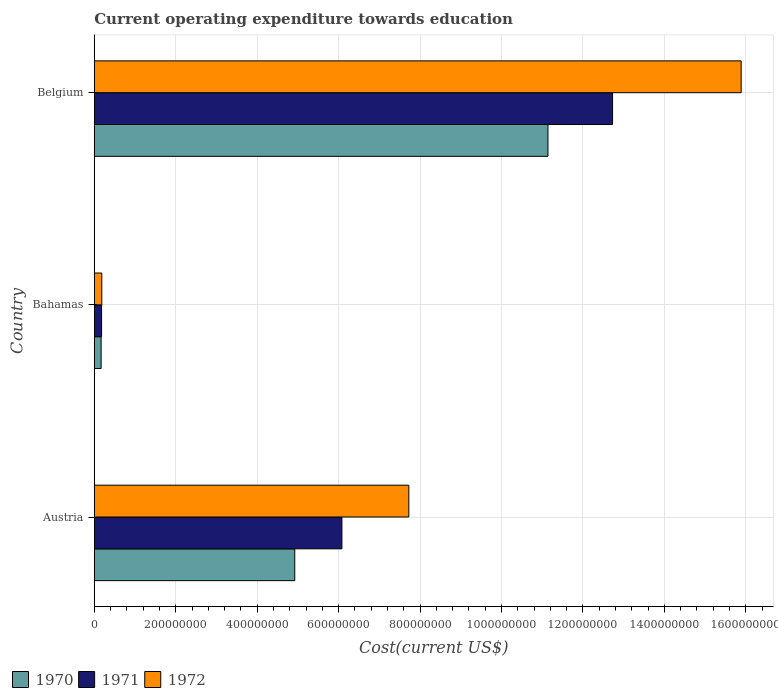How many groups of bars are there?
Your answer should be very brief. 3. Are the number of bars per tick equal to the number of legend labels?
Your answer should be compact. Yes. How many bars are there on the 1st tick from the top?
Offer a very short reply. 3. How many bars are there on the 3rd tick from the bottom?
Your response must be concise. 3. What is the label of the 2nd group of bars from the top?
Make the answer very short. Bahamas. What is the expenditure towards education in 1972 in Bahamas?
Your answer should be compact. 1.85e+07. Across all countries, what is the maximum expenditure towards education in 1970?
Offer a very short reply. 1.11e+09. Across all countries, what is the minimum expenditure towards education in 1972?
Ensure brevity in your answer.  1.85e+07. In which country was the expenditure towards education in 1970 maximum?
Ensure brevity in your answer.  Belgium. In which country was the expenditure towards education in 1971 minimum?
Your answer should be compact. Bahamas. What is the total expenditure towards education in 1970 in the graph?
Give a very brief answer. 1.62e+09. What is the difference between the expenditure towards education in 1971 in Bahamas and that in Belgium?
Your response must be concise. -1.26e+09. What is the difference between the expenditure towards education in 1970 in Bahamas and the expenditure towards education in 1972 in Belgium?
Offer a terse response. -1.57e+09. What is the average expenditure towards education in 1970 per country?
Offer a very short reply. 5.41e+08. What is the difference between the expenditure towards education in 1972 and expenditure towards education in 1971 in Bahamas?
Your response must be concise. 5.46e+05. What is the ratio of the expenditure towards education in 1970 in Austria to that in Bahamas?
Give a very brief answer. 29.29. Is the expenditure towards education in 1972 in Austria less than that in Belgium?
Provide a succinct answer. Yes. Is the difference between the expenditure towards education in 1972 in Austria and Bahamas greater than the difference between the expenditure towards education in 1971 in Austria and Bahamas?
Your answer should be very brief. Yes. What is the difference between the highest and the second highest expenditure towards education in 1971?
Offer a very short reply. 6.65e+08. What is the difference between the highest and the lowest expenditure towards education in 1971?
Provide a succinct answer. 1.26e+09. In how many countries, is the expenditure towards education in 1972 greater than the average expenditure towards education in 1972 taken over all countries?
Keep it short and to the point. 1. What does the 3rd bar from the top in Bahamas represents?
Ensure brevity in your answer.  1970. What does the 2nd bar from the bottom in Belgium represents?
Your answer should be compact. 1971. Is it the case that in every country, the sum of the expenditure towards education in 1970 and expenditure towards education in 1971 is greater than the expenditure towards education in 1972?
Your response must be concise. Yes. Are all the bars in the graph horizontal?
Provide a short and direct response. Yes. How many countries are there in the graph?
Your answer should be compact. 3. Does the graph contain any zero values?
Your answer should be very brief. No. Does the graph contain grids?
Provide a succinct answer. Yes. How many legend labels are there?
Keep it short and to the point. 3. How are the legend labels stacked?
Offer a terse response. Horizontal. What is the title of the graph?
Keep it short and to the point. Current operating expenditure towards education. Does "1992" appear as one of the legend labels in the graph?
Keep it short and to the point. No. What is the label or title of the X-axis?
Give a very brief answer. Cost(current US$). What is the Cost(current US$) in 1970 in Austria?
Ensure brevity in your answer.  4.92e+08. What is the Cost(current US$) in 1971 in Austria?
Offer a terse response. 6.08e+08. What is the Cost(current US$) in 1972 in Austria?
Keep it short and to the point. 7.73e+08. What is the Cost(current US$) of 1970 in Bahamas?
Your answer should be very brief. 1.68e+07. What is the Cost(current US$) of 1971 in Bahamas?
Offer a terse response. 1.79e+07. What is the Cost(current US$) of 1972 in Bahamas?
Ensure brevity in your answer.  1.85e+07. What is the Cost(current US$) of 1970 in Belgium?
Offer a terse response. 1.11e+09. What is the Cost(current US$) of 1971 in Belgium?
Your answer should be compact. 1.27e+09. What is the Cost(current US$) in 1972 in Belgium?
Your response must be concise. 1.59e+09. Across all countries, what is the maximum Cost(current US$) of 1970?
Offer a terse response. 1.11e+09. Across all countries, what is the maximum Cost(current US$) in 1971?
Make the answer very short. 1.27e+09. Across all countries, what is the maximum Cost(current US$) of 1972?
Your answer should be very brief. 1.59e+09. Across all countries, what is the minimum Cost(current US$) in 1970?
Provide a succinct answer. 1.68e+07. Across all countries, what is the minimum Cost(current US$) of 1971?
Give a very brief answer. 1.79e+07. Across all countries, what is the minimum Cost(current US$) in 1972?
Your answer should be very brief. 1.85e+07. What is the total Cost(current US$) of 1970 in the graph?
Offer a very short reply. 1.62e+09. What is the total Cost(current US$) of 1971 in the graph?
Offer a very short reply. 1.90e+09. What is the total Cost(current US$) of 1972 in the graph?
Your answer should be compact. 2.38e+09. What is the difference between the Cost(current US$) in 1970 in Austria and that in Bahamas?
Your response must be concise. 4.76e+08. What is the difference between the Cost(current US$) of 1971 in Austria and that in Bahamas?
Your response must be concise. 5.90e+08. What is the difference between the Cost(current US$) of 1972 in Austria and that in Bahamas?
Make the answer very short. 7.54e+08. What is the difference between the Cost(current US$) in 1970 in Austria and that in Belgium?
Your answer should be very brief. -6.22e+08. What is the difference between the Cost(current US$) in 1971 in Austria and that in Belgium?
Give a very brief answer. -6.65e+08. What is the difference between the Cost(current US$) of 1972 in Austria and that in Belgium?
Your answer should be compact. -8.16e+08. What is the difference between the Cost(current US$) in 1970 in Bahamas and that in Belgium?
Your answer should be compact. -1.10e+09. What is the difference between the Cost(current US$) of 1971 in Bahamas and that in Belgium?
Keep it short and to the point. -1.26e+09. What is the difference between the Cost(current US$) in 1972 in Bahamas and that in Belgium?
Provide a short and direct response. -1.57e+09. What is the difference between the Cost(current US$) of 1970 in Austria and the Cost(current US$) of 1971 in Bahamas?
Your answer should be very brief. 4.74e+08. What is the difference between the Cost(current US$) in 1970 in Austria and the Cost(current US$) in 1972 in Bahamas?
Your answer should be very brief. 4.74e+08. What is the difference between the Cost(current US$) in 1971 in Austria and the Cost(current US$) in 1972 in Bahamas?
Offer a very short reply. 5.90e+08. What is the difference between the Cost(current US$) of 1970 in Austria and the Cost(current US$) of 1971 in Belgium?
Your answer should be very brief. -7.81e+08. What is the difference between the Cost(current US$) in 1970 in Austria and the Cost(current US$) in 1972 in Belgium?
Ensure brevity in your answer.  -1.10e+09. What is the difference between the Cost(current US$) in 1971 in Austria and the Cost(current US$) in 1972 in Belgium?
Your answer should be very brief. -9.81e+08. What is the difference between the Cost(current US$) of 1970 in Bahamas and the Cost(current US$) of 1971 in Belgium?
Your answer should be compact. -1.26e+09. What is the difference between the Cost(current US$) in 1970 in Bahamas and the Cost(current US$) in 1972 in Belgium?
Your response must be concise. -1.57e+09. What is the difference between the Cost(current US$) of 1971 in Bahamas and the Cost(current US$) of 1972 in Belgium?
Keep it short and to the point. -1.57e+09. What is the average Cost(current US$) in 1970 per country?
Offer a terse response. 5.41e+08. What is the average Cost(current US$) of 1971 per country?
Your answer should be compact. 6.33e+08. What is the average Cost(current US$) in 1972 per country?
Offer a very short reply. 7.93e+08. What is the difference between the Cost(current US$) of 1970 and Cost(current US$) of 1971 in Austria?
Keep it short and to the point. -1.16e+08. What is the difference between the Cost(current US$) of 1970 and Cost(current US$) of 1972 in Austria?
Make the answer very short. -2.80e+08. What is the difference between the Cost(current US$) of 1971 and Cost(current US$) of 1972 in Austria?
Provide a short and direct response. -1.64e+08. What is the difference between the Cost(current US$) of 1970 and Cost(current US$) of 1971 in Bahamas?
Give a very brief answer. -1.09e+06. What is the difference between the Cost(current US$) of 1970 and Cost(current US$) of 1972 in Bahamas?
Ensure brevity in your answer.  -1.64e+06. What is the difference between the Cost(current US$) in 1971 and Cost(current US$) in 1972 in Bahamas?
Your response must be concise. -5.46e+05. What is the difference between the Cost(current US$) in 1970 and Cost(current US$) in 1971 in Belgium?
Provide a succinct answer. -1.59e+08. What is the difference between the Cost(current US$) of 1970 and Cost(current US$) of 1972 in Belgium?
Ensure brevity in your answer.  -4.74e+08. What is the difference between the Cost(current US$) in 1971 and Cost(current US$) in 1972 in Belgium?
Keep it short and to the point. -3.16e+08. What is the ratio of the Cost(current US$) of 1970 in Austria to that in Bahamas?
Your answer should be very brief. 29.29. What is the ratio of the Cost(current US$) in 1971 in Austria to that in Bahamas?
Your answer should be very brief. 33.97. What is the ratio of the Cost(current US$) of 1972 in Austria to that in Bahamas?
Ensure brevity in your answer.  41.87. What is the ratio of the Cost(current US$) in 1970 in Austria to that in Belgium?
Provide a short and direct response. 0.44. What is the ratio of the Cost(current US$) of 1971 in Austria to that in Belgium?
Offer a terse response. 0.48. What is the ratio of the Cost(current US$) in 1972 in Austria to that in Belgium?
Make the answer very short. 0.49. What is the ratio of the Cost(current US$) in 1970 in Bahamas to that in Belgium?
Keep it short and to the point. 0.02. What is the ratio of the Cost(current US$) of 1971 in Bahamas to that in Belgium?
Keep it short and to the point. 0.01. What is the ratio of the Cost(current US$) in 1972 in Bahamas to that in Belgium?
Your answer should be very brief. 0.01. What is the difference between the highest and the second highest Cost(current US$) of 1970?
Provide a short and direct response. 6.22e+08. What is the difference between the highest and the second highest Cost(current US$) of 1971?
Your answer should be compact. 6.65e+08. What is the difference between the highest and the second highest Cost(current US$) of 1972?
Ensure brevity in your answer.  8.16e+08. What is the difference between the highest and the lowest Cost(current US$) of 1970?
Your answer should be compact. 1.10e+09. What is the difference between the highest and the lowest Cost(current US$) in 1971?
Provide a short and direct response. 1.26e+09. What is the difference between the highest and the lowest Cost(current US$) in 1972?
Ensure brevity in your answer.  1.57e+09. 